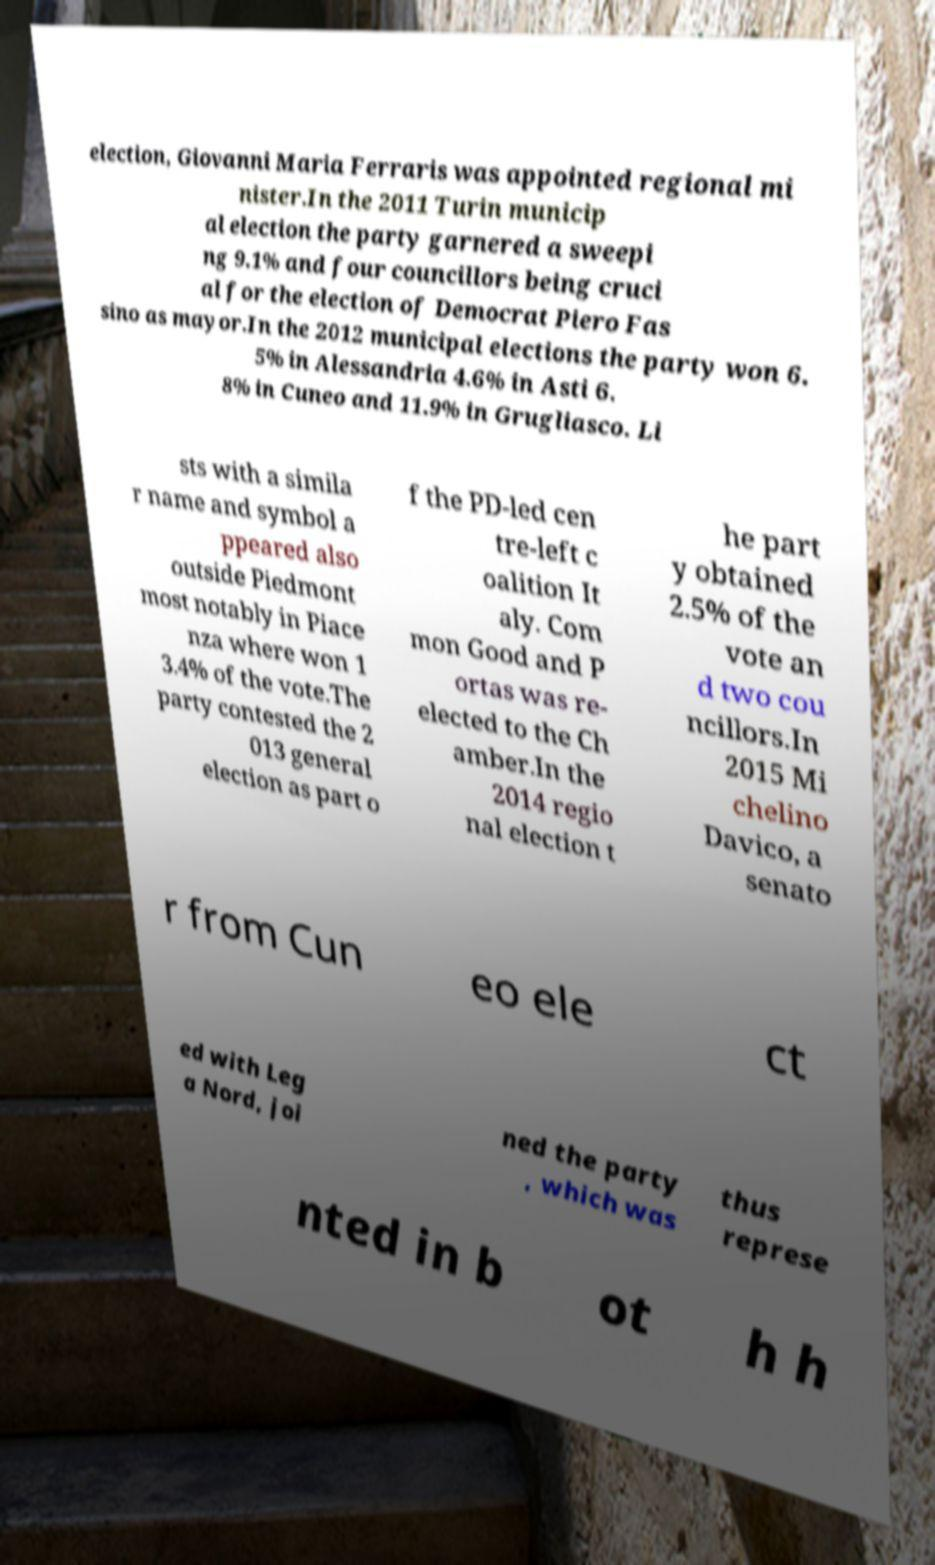Could you assist in decoding the text presented in this image and type it out clearly? election, Giovanni Maria Ferraris was appointed regional mi nister.In the 2011 Turin municip al election the party garnered a sweepi ng 9.1% and four councillors being cruci al for the election of Democrat Piero Fas sino as mayor.In the 2012 municipal elections the party won 6. 5% in Alessandria 4.6% in Asti 6. 8% in Cuneo and 11.9% in Grugliasco. Li sts with a simila r name and symbol a ppeared also outside Piedmont most notably in Piace nza where won 1 3.4% of the vote.The party contested the 2 013 general election as part o f the PD-led cen tre-left c oalition It aly. Com mon Good and P ortas was re- elected to the Ch amber.In the 2014 regio nal election t he part y obtained 2.5% of the vote an d two cou ncillors.In 2015 Mi chelino Davico, a senato r from Cun eo ele ct ed with Leg a Nord, joi ned the party , which was thus represe nted in b ot h h 